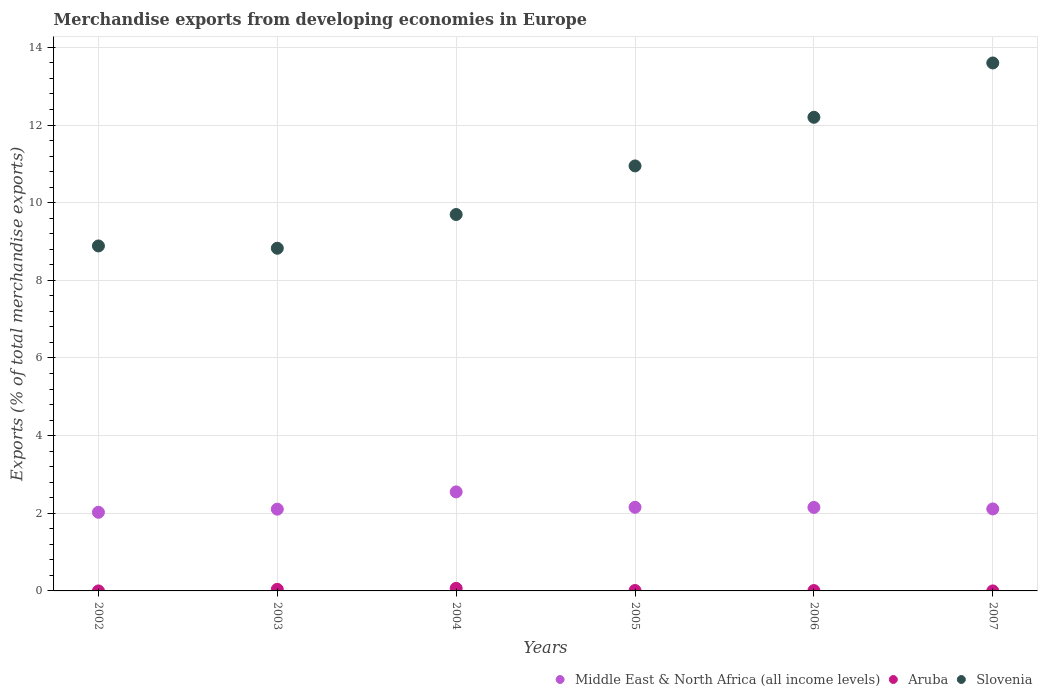How many different coloured dotlines are there?
Ensure brevity in your answer.  3. Is the number of dotlines equal to the number of legend labels?
Your answer should be very brief. Yes. What is the percentage of total merchandise exports in Slovenia in 2007?
Offer a terse response. 13.6. Across all years, what is the maximum percentage of total merchandise exports in Slovenia?
Make the answer very short. 13.6. Across all years, what is the minimum percentage of total merchandise exports in Slovenia?
Keep it short and to the point. 8.83. What is the total percentage of total merchandise exports in Slovenia in the graph?
Ensure brevity in your answer.  64.15. What is the difference between the percentage of total merchandise exports in Aruba in 2003 and that in 2006?
Keep it short and to the point. 0.03. What is the difference between the percentage of total merchandise exports in Middle East & North Africa (all income levels) in 2006 and the percentage of total merchandise exports in Aruba in 2007?
Offer a very short reply. 2.15. What is the average percentage of total merchandise exports in Middle East & North Africa (all income levels) per year?
Offer a very short reply. 2.18. In the year 2004, what is the difference between the percentage of total merchandise exports in Aruba and percentage of total merchandise exports in Slovenia?
Keep it short and to the point. -9.63. In how many years, is the percentage of total merchandise exports in Slovenia greater than 12.8 %?
Your answer should be very brief. 1. What is the ratio of the percentage of total merchandise exports in Slovenia in 2005 to that in 2006?
Your answer should be very brief. 0.9. Is the percentage of total merchandise exports in Slovenia in 2003 less than that in 2006?
Give a very brief answer. Yes. Is the difference between the percentage of total merchandise exports in Aruba in 2002 and 2003 greater than the difference between the percentage of total merchandise exports in Slovenia in 2002 and 2003?
Your response must be concise. No. What is the difference between the highest and the second highest percentage of total merchandise exports in Aruba?
Give a very brief answer. 0.03. What is the difference between the highest and the lowest percentage of total merchandise exports in Aruba?
Make the answer very short. 0.07. Is the sum of the percentage of total merchandise exports in Slovenia in 2002 and 2005 greater than the maximum percentage of total merchandise exports in Middle East & North Africa (all income levels) across all years?
Offer a very short reply. Yes. Does the percentage of total merchandise exports in Aruba monotonically increase over the years?
Your response must be concise. No. Is the percentage of total merchandise exports in Slovenia strictly greater than the percentage of total merchandise exports in Aruba over the years?
Give a very brief answer. Yes. Is the percentage of total merchandise exports in Slovenia strictly less than the percentage of total merchandise exports in Aruba over the years?
Offer a very short reply. No. How many dotlines are there?
Provide a short and direct response. 3. How many years are there in the graph?
Make the answer very short. 6. What is the difference between two consecutive major ticks on the Y-axis?
Give a very brief answer. 2. Where does the legend appear in the graph?
Give a very brief answer. Bottom right. How many legend labels are there?
Offer a terse response. 3. What is the title of the graph?
Ensure brevity in your answer.  Merchandise exports from developing economies in Europe. What is the label or title of the Y-axis?
Offer a very short reply. Exports (% of total merchandise exports). What is the Exports (% of total merchandise exports) of Middle East & North Africa (all income levels) in 2002?
Your answer should be compact. 2.03. What is the Exports (% of total merchandise exports) of Aruba in 2002?
Your answer should be very brief. 0. What is the Exports (% of total merchandise exports) in Slovenia in 2002?
Your response must be concise. 8.89. What is the Exports (% of total merchandise exports) in Middle East & North Africa (all income levels) in 2003?
Your answer should be compact. 2.11. What is the Exports (% of total merchandise exports) in Aruba in 2003?
Make the answer very short. 0.04. What is the Exports (% of total merchandise exports) of Slovenia in 2003?
Keep it short and to the point. 8.83. What is the Exports (% of total merchandise exports) of Middle East & North Africa (all income levels) in 2004?
Provide a short and direct response. 2.55. What is the Exports (% of total merchandise exports) in Aruba in 2004?
Offer a very short reply. 0.07. What is the Exports (% of total merchandise exports) of Slovenia in 2004?
Offer a very short reply. 9.7. What is the Exports (% of total merchandise exports) of Middle East & North Africa (all income levels) in 2005?
Your answer should be very brief. 2.15. What is the Exports (% of total merchandise exports) in Aruba in 2005?
Provide a short and direct response. 0.01. What is the Exports (% of total merchandise exports) of Slovenia in 2005?
Offer a very short reply. 10.95. What is the Exports (% of total merchandise exports) of Middle East & North Africa (all income levels) in 2006?
Give a very brief answer. 2.15. What is the Exports (% of total merchandise exports) in Aruba in 2006?
Provide a succinct answer. 0.01. What is the Exports (% of total merchandise exports) of Slovenia in 2006?
Your answer should be very brief. 12.2. What is the Exports (% of total merchandise exports) of Middle East & North Africa (all income levels) in 2007?
Keep it short and to the point. 2.11. What is the Exports (% of total merchandise exports) of Aruba in 2007?
Offer a very short reply. 0. What is the Exports (% of total merchandise exports) in Slovenia in 2007?
Provide a short and direct response. 13.6. Across all years, what is the maximum Exports (% of total merchandise exports) in Middle East & North Africa (all income levels)?
Your response must be concise. 2.55. Across all years, what is the maximum Exports (% of total merchandise exports) in Aruba?
Offer a terse response. 0.07. Across all years, what is the maximum Exports (% of total merchandise exports) in Slovenia?
Provide a succinct answer. 13.6. Across all years, what is the minimum Exports (% of total merchandise exports) in Middle East & North Africa (all income levels)?
Offer a terse response. 2.03. Across all years, what is the minimum Exports (% of total merchandise exports) of Aruba?
Keep it short and to the point. 0. Across all years, what is the minimum Exports (% of total merchandise exports) of Slovenia?
Your answer should be very brief. 8.83. What is the total Exports (% of total merchandise exports) of Middle East & North Africa (all income levels) in the graph?
Offer a terse response. 13.1. What is the total Exports (% of total merchandise exports) in Aruba in the graph?
Offer a very short reply. 0.13. What is the total Exports (% of total merchandise exports) of Slovenia in the graph?
Offer a very short reply. 64.15. What is the difference between the Exports (% of total merchandise exports) of Middle East & North Africa (all income levels) in 2002 and that in 2003?
Keep it short and to the point. -0.08. What is the difference between the Exports (% of total merchandise exports) in Aruba in 2002 and that in 2003?
Make the answer very short. -0.04. What is the difference between the Exports (% of total merchandise exports) of Slovenia in 2002 and that in 2003?
Provide a succinct answer. 0.06. What is the difference between the Exports (% of total merchandise exports) in Middle East & North Africa (all income levels) in 2002 and that in 2004?
Give a very brief answer. -0.53. What is the difference between the Exports (% of total merchandise exports) in Aruba in 2002 and that in 2004?
Your response must be concise. -0.07. What is the difference between the Exports (% of total merchandise exports) in Slovenia in 2002 and that in 2004?
Your answer should be compact. -0.81. What is the difference between the Exports (% of total merchandise exports) in Middle East & North Africa (all income levels) in 2002 and that in 2005?
Offer a very short reply. -0.13. What is the difference between the Exports (% of total merchandise exports) in Aruba in 2002 and that in 2005?
Make the answer very short. -0.01. What is the difference between the Exports (% of total merchandise exports) in Slovenia in 2002 and that in 2005?
Provide a succinct answer. -2.06. What is the difference between the Exports (% of total merchandise exports) in Middle East & North Africa (all income levels) in 2002 and that in 2006?
Keep it short and to the point. -0.12. What is the difference between the Exports (% of total merchandise exports) in Aruba in 2002 and that in 2006?
Provide a short and direct response. -0.01. What is the difference between the Exports (% of total merchandise exports) in Slovenia in 2002 and that in 2006?
Provide a short and direct response. -3.31. What is the difference between the Exports (% of total merchandise exports) of Middle East & North Africa (all income levels) in 2002 and that in 2007?
Offer a terse response. -0.09. What is the difference between the Exports (% of total merchandise exports) of Slovenia in 2002 and that in 2007?
Make the answer very short. -4.71. What is the difference between the Exports (% of total merchandise exports) of Middle East & North Africa (all income levels) in 2003 and that in 2004?
Your answer should be compact. -0.45. What is the difference between the Exports (% of total merchandise exports) of Aruba in 2003 and that in 2004?
Offer a terse response. -0.03. What is the difference between the Exports (% of total merchandise exports) in Slovenia in 2003 and that in 2004?
Provide a succinct answer. -0.87. What is the difference between the Exports (% of total merchandise exports) in Middle East & North Africa (all income levels) in 2003 and that in 2005?
Offer a very short reply. -0.05. What is the difference between the Exports (% of total merchandise exports) in Aruba in 2003 and that in 2005?
Make the answer very short. 0.03. What is the difference between the Exports (% of total merchandise exports) in Slovenia in 2003 and that in 2005?
Offer a terse response. -2.12. What is the difference between the Exports (% of total merchandise exports) in Middle East & North Africa (all income levels) in 2003 and that in 2006?
Provide a short and direct response. -0.04. What is the difference between the Exports (% of total merchandise exports) in Aruba in 2003 and that in 2006?
Make the answer very short. 0.03. What is the difference between the Exports (% of total merchandise exports) of Slovenia in 2003 and that in 2006?
Your response must be concise. -3.37. What is the difference between the Exports (% of total merchandise exports) in Middle East & North Africa (all income levels) in 2003 and that in 2007?
Keep it short and to the point. -0.01. What is the difference between the Exports (% of total merchandise exports) in Aruba in 2003 and that in 2007?
Ensure brevity in your answer.  0.04. What is the difference between the Exports (% of total merchandise exports) of Slovenia in 2003 and that in 2007?
Your answer should be compact. -4.77. What is the difference between the Exports (% of total merchandise exports) of Middle East & North Africa (all income levels) in 2004 and that in 2005?
Your answer should be very brief. 0.4. What is the difference between the Exports (% of total merchandise exports) of Aruba in 2004 and that in 2005?
Make the answer very short. 0.06. What is the difference between the Exports (% of total merchandise exports) of Slovenia in 2004 and that in 2005?
Your answer should be very brief. -1.25. What is the difference between the Exports (% of total merchandise exports) in Middle East & North Africa (all income levels) in 2004 and that in 2006?
Offer a terse response. 0.4. What is the difference between the Exports (% of total merchandise exports) of Aruba in 2004 and that in 2006?
Provide a succinct answer. 0.06. What is the difference between the Exports (% of total merchandise exports) in Slovenia in 2004 and that in 2006?
Provide a short and direct response. -2.5. What is the difference between the Exports (% of total merchandise exports) of Middle East & North Africa (all income levels) in 2004 and that in 2007?
Give a very brief answer. 0.44. What is the difference between the Exports (% of total merchandise exports) in Aruba in 2004 and that in 2007?
Your answer should be very brief. 0.07. What is the difference between the Exports (% of total merchandise exports) in Slovenia in 2004 and that in 2007?
Your answer should be compact. -3.9. What is the difference between the Exports (% of total merchandise exports) of Middle East & North Africa (all income levels) in 2005 and that in 2006?
Offer a terse response. 0. What is the difference between the Exports (% of total merchandise exports) of Aruba in 2005 and that in 2006?
Offer a terse response. 0. What is the difference between the Exports (% of total merchandise exports) of Slovenia in 2005 and that in 2006?
Your answer should be compact. -1.25. What is the difference between the Exports (% of total merchandise exports) of Middle East & North Africa (all income levels) in 2005 and that in 2007?
Make the answer very short. 0.04. What is the difference between the Exports (% of total merchandise exports) of Aruba in 2005 and that in 2007?
Your answer should be compact. 0.01. What is the difference between the Exports (% of total merchandise exports) in Slovenia in 2005 and that in 2007?
Your answer should be very brief. -2.65. What is the difference between the Exports (% of total merchandise exports) of Middle East & North Africa (all income levels) in 2006 and that in 2007?
Provide a succinct answer. 0.04. What is the difference between the Exports (% of total merchandise exports) of Aruba in 2006 and that in 2007?
Your answer should be compact. 0.01. What is the difference between the Exports (% of total merchandise exports) in Slovenia in 2006 and that in 2007?
Provide a succinct answer. -1.4. What is the difference between the Exports (% of total merchandise exports) in Middle East & North Africa (all income levels) in 2002 and the Exports (% of total merchandise exports) in Aruba in 2003?
Make the answer very short. 1.99. What is the difference between the Exports (% of total merchandise exports) of Middle East & North Africa (all income levels) in 2002 and the Exports (% of total merchandise exports) of Slovenia in 2003?
Provide a short and direct response. -6.8. What is the difference between the Exports (% of total merchandise exports) of Aruba in 2002 and the Exports (% of total merchandise exports) of Slovenia in 2003?
Give a very brief answer. -8.83. What is the difference between the Exports (% of total merchandise exports) of Middle East & North Africa (all income levels) in 2002 and the Exports (% of total merchandise exports) of Aruba in 2004?
Make the answer very short. 1.96. What is the difference between the Exports (% of total merchandise exports) of Middle East & North Africa (all income levels) in 2002 and the Exports (% of total merchandise exports) of Slovenia in 2004?
Provide a succinct answer. -7.67. What is the difference between the Exports (% of total merchandise exports) in Aruba in 2002 and the Exports (% of total merchandise exports) in Slovenia in 2004?
Keep it short and to the point. -9.7. What is the difference between the Exports (% of total merchandise exports) of Middle East & North Africa (all income levels) in 2002 and the Exports (% of total merchandise exports) of Aruba in 2005?
Your response must be concise. 2.01. What is the difference between the Exports (% of total merchandise exports) in Middle East & North Africa (all income levels) in 2002 and the Exports (% of total merchandise exports) in Slovenia in 2005?
Your response must be concise. -8.92. What is the difference between the Exports (% of total merchandise exports) in Aruba in 2002 and the Exports (% of total merchandise exports) in Slovenia in 2005?
Offer a terse response. -10.95. What is the difference between the Exports (% of total merchandise exports) in Middle East & North Africa (all income levels) in 2002 and the Exports (% of total merchandise exports) in Aruba in 2006?
Make the answer very short. 2.02. What is the difference between the Exports (% of total merchandise exports) in Middle East & North Africa (all income levels) in 2002 and the Exports (% of total merchandise exports) in Slovenia in 2006?
Give a very brief answer. -10.17. What is the difference between the Exports (% of total merchandise exports) of Aruba in 2002 and the Exports (% of total merchandise exports) of Slovenia in 2006?
Keep it short and to the point. -12.2. What is the difference between the Exports (% of total merchandise exports) of Middle East & North Africa (all income levels) in 2002 and the Exports (% of total merchandise exports) of Aruba in 2007?
Ensure brevity in your answer.  2.03. What is the difference between the Exports (% of total merchandise exports) of Middle East & North Africa (all income levels) in 2002 and the Exports (% of total merchandise exports) of Slovenia in 2007?
Offer a very short reply. -11.57. What is the difference between the Exports (% of total merchandise exports) in Aruba in 2002 and the Exports (% of total merchandise exports) in Slovenia in 2007?
Give a very brief answer. -13.6. What is the difference between the Exports (% of total merchandise exports) of Middle East & North Africa (all income levels) in 2003 and the Exports (% of total merchandise exports) of Aruba in 2004?
Your response must be concise. 2.04. What is the difference between the Exports (% of total merchandise exports) of Middle East & North Africa (all income levels) in 2003 and the Exports (% of total merchandise exports) of Slovenia in 2004?
Provide a succinct answer. -7.59. What is the difference between the Exports (% of total merchandise exports) of Aruba in 2003 and the Exports (% of total merchandise exports) of Slovenia in 2004?
Give a very brief answer. -9.65. What is the difference between the Exports (% of total merchandise exports) in Middle East & North Africa (all income levels) in 2003 and the Exports (% of total merchandise exports) in Aruba in 2005?
Your response must be concise. 2.09. What is the difference between the Exports (% of total merchandise exports) of Middle East & North Africa (all income levels) in 2003 and the Exports (% of total merchandise exports) of Slovenia in 2005?
Keep it short and to the point. -8.84. What is the difference between the Exports (% of total merchandise exports) of Aruba in 2003 and the Exports (% of total merchandise exports) of Slovenia in 2005?
Offer a terse response. -10.91. What is the difference between the Exports (% of total merchandise exports) of Middle East & North Africa (all income levels) in 2003 and the Exports (% of total merchandise exports) of Aruba in 2006?
Your response must be concise. 2.1. What is the difference between the Exports (% of total merchandise exports) of Middle East & North Africa (all income levels) in 2003 and the Exports (% of total merchandise exports) of Slovenia in 2006?
Offer a very short reply. -10.09. What is the difference between the Exports (% of total merchandise exports) in Aruba in 2003 and the Exports (% of total merchandise exports) in Slovenia in 2006?
Offer a terse response. -12.16. What is the difference between the Exports (% of total merchandise exports) of Middle East & North Africa (all income levels) in 2003 and the Exports (% of total merchandise exports) of Aruba in 2007?
Your answer should be very brief. 2.11. What is the difference between the Exports (% of total merchandise exports) in Middle East & North Africa (all income levels) in 2003 and the Exports (% of total merchandise exports) in Slovenia in 2007?
Make the answer very short. -11.49. What is the difference between the Exports (% of total merchandise exports) of Aruba in 2003 and the Exports (% of total merchandise exports) of Slovenia in 2007?
Your response must be concise. -13.56. What is the difference between the Exports (% of total merchandise exports) of Middle East & North Africa (all income levels) in 2004 and the Exports (% of total merchandise exports) of Aruba in 2005?
Your response must be concise. 2.54. What is the difference between the Exports (% of total merchandise exports) of Middle East & North Africa (all income levels) in 2004 and the Exports (% of total merchandise exports) of Slovenia in 2005?
Your response must be concise. -8.4. What is the difference between the Exports (% of total merchandise exports) of Aruba in 2004 and the Exports (% of total merchandise exports) of Slovenia in 2005?
Give a very brief answer. -10.88. What is the difference between the Exports (% of total merchandise exports) of Middle East & North Africa (all income levels) in 2004 and the Exports (% of total merchandise exports) of Aruba in 2006?
Give a very brief answer. 2.54. What is the difference between the Exports (% of total merchandise exports) in Middle East & North Africa (all income levels) in 2004 and the Exports (% of total merchandise exports) in Slovenia in 2006?
Ensure brevity in your answer.  -9.65. What is the difference between the Exports (% of total merchandise exports) in Aruba in 2004 and the Exports (% of total merchandise exports) in Slovenia in 2006?
Make the answer very short. -12.13. What is the difference between the Exports (% of total merchandise exports) of Middle East & North Africa (all income levels) in 2004 and the Exports (% of total merchandise exports) of Aruba in 2007?
Your answer should be very brief. 2.55. What is the difference between the Exports (% of total merchandise exports) in Middle East & North Africa (all income levels) in 2004 and the Exports (% of total merchandise exports) in Slovenia in 2007?
Your answer should be very brief. -11.05. What is the difference between the Exports (% of total merchandise exports) in Aruba in 2004 and the Exports (% of total merchandise exports) in Slovenia in 2007?
Ensure brevity in your answer.  -13.53. What is the difference between the Exports (% of total merchandise exports) of Middle East & North Africa (all income levels) in 2005 and the Exports (% of total merchandise exports) of Aruba in 2006?
Provide a short and direct response. 2.14. What is the difference between the Exports (% of total merchandise exports) in Middle East & North Africa (all income levels) in 2005 and the Exports (% of total merchandise exports) in Slovenia in 2006?
Provide a succinct answer. -10.05. What is the difference between the Exports (% of total merchandise exports) in Aruba in 2005 and the Exports (% of total merchandise exports) in Slovenia in 2006?
Offer a terse response. -12.19. What is the difference between the Exports (% of total merchandise exports) of Middle East & North Africa (all income levels) in 2005 and the Exports (% of total merchandise exports) of Aruba in 2007?
Your response must be concise. 2.15. What is the difference between the Exports (% of total merchandise exports) of Middle East & North Africa (all income levels) in 2005 and the Exports (% of total merchandise exports) of Slovenia in 2007?
Provide a succinct answer. -11.44. What is the difference between the Exports (% of total merchandise exports) in Aruba in 2005 and the Exports (% of total merchandise exports) in Slovenia in 2007?
Provide a succinct answer. -13.59. What is the difference between the Exports (% of total merchandise exports) in Middle East & North Africa (all income levels) in 2006 and the Exports (% of total merchandise exports) in Aruba in 2007?
Ensure brevity in your answer.  2.15. What is the difference between the Exports (% of total merchandise exports) of Middle East & North Africa (all income levels) in 2006 and the Exports (% of total merchandise exports) of Slovenia in 2007?
Your answer should be very brief. -11.45. What is the difference between the Exports (% of total merchandise exports) in Aruba in 2006 and the Exports (% of total merchandise exports) in Slovenia in 2007?
Keep it short and to the point. -13.59. What is the average Exports (% of total merchandise exports) in Middle East & North Africa (all income levels) per year?
Your response must be concise. 2.18. What is the average Exports (% of total merchandise exports) of Aruba per year?
Offer a very short reply. 0.02. What is the average Exports (% of total merchandise exports) of Slovenia per year?
Make the answer very short. 10.69. In the year 2002, what is the difference between the Exports (% of total merchandise exports) of Middle East & North Africa (all income levels) and Exports (% of total merchandise exports) of Aruba?
Your response must be concise. 2.03. In the year 2002, what is the difference between the Exports (% of total merchandise exports) of Middle East & North Africa (all income levels) and Exports (% of total merchandise exports) of Slovenia?
Keep it short and to the point. -6.86. In the year 2002, what is the difference between the Exports (% of total merchandise exports) in Aruba and Exports (% of total merchandise exports) in Slovenia?
Offer a terse response. -8.89. In the year 2003, what is the difference between the Exports (% of total merchandise exports) in Middle East & North Africa (all income levels) and Exports (% of total merchandise exports) in Aruba?
Provide a short and direct response. 2.07. In the year 2003, what is the difference between the Exports (% of total merchandise exports) of Middle East & North Africa (all income levels) and Exports (% of total merchandise exports) of Slovenia?
Keep it short and to the point. -6.72. In the year 2003, what is the difference between the Exports (% of total merchandise exports) in Aruba and Exports (% of total merchandise exports) in Slovenia?
Offer a very short reply. -8.79. In the year 2004, what is the difference between the Exports (% of total merchandise exports) of Middle East & North Africa (all income levels) and Exports (% of total merchandise exports) of Aruba?
Offer a terse response. 2.48. In the year 2004, what is the difference between the Exports (% of total merchandise exports) of Middle East & North Africa (all income levels) and Exports (% of total merchandise exports) of Slovenia?
Your answer should be very brief. -7.14. In the year 2004, what is the difference between the Exports (% of total merchandise exports) in Aruba and Exports (% of total merchandise exports) in Slovenia?
Your response must be concise. -9.63. In the year 2005, what is the difference between the Exports (% of total merchandise exports) in Middle East & North Africa (all income levels) and Exports (% of total merchandise exports) in Aruba?
Your answer should be compact. 2.14. In the year 2005, what is the difference between the Exports (% of total merchandise exports) in Middle East & North Africa (all income levels) and Exports (% of total merchandise exports) in Slovenia?
Keep it short and to the point. -8.79. In the year 2005, what is the difference between the Exports (% of total merchandise exports) in Aruba and Exports (% of total merchandise exports) in Slovenia?
Offer a very short reply. -10.94. In the year 2006, what is the difference between the Exports (% of total merchandise exports) in Middle East & North Africa (all income levels) and Exports (% of total merchandise exports) in Aruba?
Offer a terse response. 2.14. In the year 2006, what is the difference between the Exports (% of total merchandise exports) in Middle East & North Africa (all income levels) and Exports (% of total merchandise exports) in Slovenia?
Provide a short and direct response. -10.05. In the year 2006, what is the difference between the Exports (% of total merchandise exports) in Aruba and Exports (% of total merchandise exports) in Slovenia?
Your answer should be compact. -12.19. In the year 2007, what is the difference between the Exports (% of total merchandise exports) in Middle East & North Africa (all income levels) and Exports (% of total merchandise exports) in Aruba?
Provide a short and direct response. 2.11. In the year 2007, what is the difference between the Exports (% of total merchandise exports) of Middle East & North Africa (all income levels) and Exports (% of total merchandise exports) of Slovenia?
Provide a short and direct response. -11.49. In the year 2007, what is the difference between the Exports (% of total merchandise exports) in Aruba and Exports (% of total merchandise exports) in Slovenia?
Keep it short and to the point. -13.6. What is the ratio of the Exports (% of total merchandise exports) of Aruba in 2002 to that in 2003?
Offer a very short reply. 0. What is the ratio of the Exports (% of total merchandise exports) in Slovenia in 2002 to that in 2003?
Provide a succinct answer. 1.01. What is the ratio of the Exports (% of total merchandise exports) of Middle East & North Africa (all income levels) in 2002 to that in 2004?
Offer a very short reply. 0.79. What is the ratio of the Exports (% of total merchandise exports) of Aruba in 2002 to that in 2004?
Ensure brevity in your answer.  0. What is the ratio of the Exports (% of total merchandise exports) of Slovenia in 2002 to that in 2004?
Make the answer very short. 0.92. What is the ratio of the Exports (% of total merchandise exports) in Middle East & North Africa (all income levels) in 2002 to that in 2005?
Provide a short and direct response. 0.94. What is the ratio of the Exports (% of total merchandise exports) in Aruba in 2002 to that in 2005?
Your answer should be very brief. 0.01. What is the ratio of the Exports (% of total merchandise exports) in Slovenia in 2002 to that in 2005?
Your answer should be very brief. 0.81. What is the ratio of the Exports (% of total merchandise exports) of Middle East & North Africa (all income levels) in 2002 to that in 2006?
Provide a succinct answer. 0.94. What is the ratio of the Exports (% of total merchandise exports) in Aruba in 2002 to that in 2006?
Provide a short and direct response. 0.01. What is the ratio of the Exports (% of total merchandise exports) in Slovenia in 2002 to that in 2006?
Offer a terse response. 0.73. What is the ratio of the Exports (% of total merchandise exports) in Middle East & North Africa (all income levels) in 2002 to that in 2007?
Offer a very short reply. 0.96. What is the ratio of the Exports (% of total merchandise exports) of Aruba in 2002 to that in 2007?
Your answer should be very brief. 1.08. What is the ratio of the Exports (% of total merchandise exports) of Slovenia in 2002 to that in 2007?
Your answer should be compact. 0.65. What is the ratio of the Exports (% of total merchandise exports) in Middle East & North Africa (all income levels) in 2003 to that in 2004?
Offer a terse response. 0.83. What is the ratio of the Exports (% of total merchandise exports) of Aruba in 2003 to that in 2004?
Offer a terse response. 0.61. What is the ratio of the Exports (% of total merchandise exports) in Slovenia in 2003 to that in 2004?
Your answer should be very brief. 0.91. What is the ratio of the Exports (% of total merchandise exports) in Middle East & North Africa (all income levels) in 2003 to that in 2005?
Your response must be concise. 0.98. What is the ratio of the Exports (% of total merchandise exports) in Aruba in 2003 to that in 2005?
Your response must be concise. 3.76. What is the ratio of the Exports (% of total merchandise exports) in Slovenia in 2003 to that in 2005?
Make the answer very short. 0.81. What is the ratio of the Exports (% of total merchandise exports) of Middle East & North Africa (all income levels) in 2003 to that in 2006?
Offer a terse response. 0.98. What is the ratio of the Exports (% of total merchandise exports) of Aruba in 2003 to that in 2006?
Provide a short and direct response. 4.37. What is the ratio of the Exports (% of total merchandise exports) in Slovenia in 2003 to that in 2006?
Make the answer very short. 0.72. What is the ratio of the Exports (% of total merchandise exports) in Aruba in 2003 to that in 2007?
Offer a very short reply. 393.01. What is the ratio of the Exports (% of total merchandise exports) of Slovenia in 2003 to that in 2007?
Provide a short and direct response. 0.65. What is the ratio of the Exports (% of total merchandise exports) in Middle East & North Africa (all income levels) in 2004 to that in 2005?
Your response must be concise. 1.18. What is the ratio of the Exports (% of total merchandise exports) of Aruba in 2004 to that in 2005?
Provide a short and direct response. 6.19. What is the ratio of the Exports (% of total merchandise exports) in Slovenia in 2004 to that in 2005?
Give a very brief answer. 0.89. What is the ratio of the Exports (% of total merchandise exports) of Middle East & North Africa (all income levels) in 2004 to that in 2006?
Offer a terse response. 1.19. What is the ratio of the Exports (% of total merchandise exports) in Aruba in 2004 to that in 2006?
Make the answer very short. 7.21. What is the ratio of the Exports (% of total merchandise exports) in Slovenia in 2004 to that in 2006?
Your response must be concise. 0.79. What is the ratio of the Exports (% of total merchandise exports) in Middle East & North Africa (all income levels) in 2004 to that in 2007?
Your answer should be very brief. 1.21. What is the ratio of the Exports (% of total merchandise exports) in Aruba in 2004 to that in 2007?
Offer a very short reply. 647.98. What is the ratio of the Exports (% of total merchandise exports) of Slovenia in 2004 to that in 2007?
Give a very brief answer. 0.71. What is the ratio of the Exports (% of total merchandise exports) of Middle East & North Africa (all income levels) in 2005 to that in 2006?
Provide a succinct answer. 1. What is the ratio of the Exports (% of total merchandise exports) of Aruba in 2005 to that in 2006?
Provide a short and direct response. 1.16. What is the ratio of the Exports (% of total merchandise exports) of Slovenia in 2005 to that in 2006?
Your answer should be very brief. 0.9. What is the ratio of the Exports (% of total merchandise exports) in Middle East & North Africa (all income levels) in 2005 to that in 2007?
Make the answer very short. 1.02. What is the ratio of the Exports (% of total merchandise exports) in Aruba in 2005 to that in 2007?
Offer a terse response. 104.64. What is the ratio of the Exports (% of total merchandise exports) in Slovenia in 2005 to that in 2007?
Provide a short and direct response. 0.81. What is the ratio of the Exports (% of total merchandise exports) in Middle East & North Africa (all income levels) in 2006 to that in 2007?
Keep it short and to the point. 1.02. What is the ratio of the Exports (% of total merchandise exports) in Aruba in 2006 to that in 2007?
Provide a short and direct response. 89.84. What is the ratio of the Exports (% of total merchandise exports) in Slovenia in 2006 to that in 2007?
Your answer should be very brief. 0.9. What is the difference between the highest and the second highest Exports (% of total merchandise exports) in Middle East & North Africa (all income levels)?
Ensure brevity in your answer.  0.4. What is the difference between the highest and the second highest Exports (% of total merchandise exports) in Aruba?
Make the answer very short. 0.03. What is the difference between the highest and the second highest Exports (% of total merchandise exports) in Slovenia?
Your answer should be very brief. 1.4. What is the difference between the highest and the lowest Exports (% of total merchandise exports) of Middle East & North Africa (all income levels)?
Your response must be concise. 0.53. What is the difference between the highest and the lowest Exports (% of total merchandise exports) in Aruba?
Ensure brevity in your answer.  0.07. What is the difference between the highest and the lowest Exports (% of total merchandise exports) in Slovenia?
Keep it short and to the point. 4.77. 